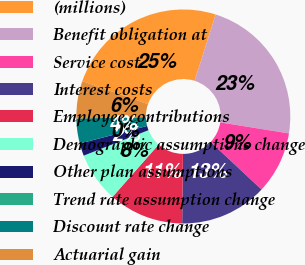Convert chart. <chart><loc_0><loc_0><loc_500><loc_500><pie_chart><fcel>(millions)<fcel>Benefit obligation at<fcel>Service cost<fcel>Interest costs<fcel>Employee contributions<fcel>Demographic assumptions change<fcel>Other plan assumptions<fcel>Trend rate assumption change<fcel>Discount rate change<fcel>Actuarial gain<nl><fcel>24.53%<fcel>22.64%<fcel>9.43%<fcel>13.21%<fcel>11.32%<fcel>7.55%<fcel>1.89%<fcel>0.0%<fcel>3.77%<fcel>5.66%<nl></chart> 